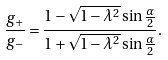Convert formula to latex. <formula><loc_0><loc_0><loc_500><loc_500>\frac { g _ { + } } { g _ { - } } = \frac { 1 - \sqrt { 1 - \lambda ^ { 2 } } \sin { \frac { \alpha } { 2 } } } { 1 + \sqrt { 1 - \lambda ^ { 2 } } \sin { \frac { \alpha } { 2 } } } .</formula> 